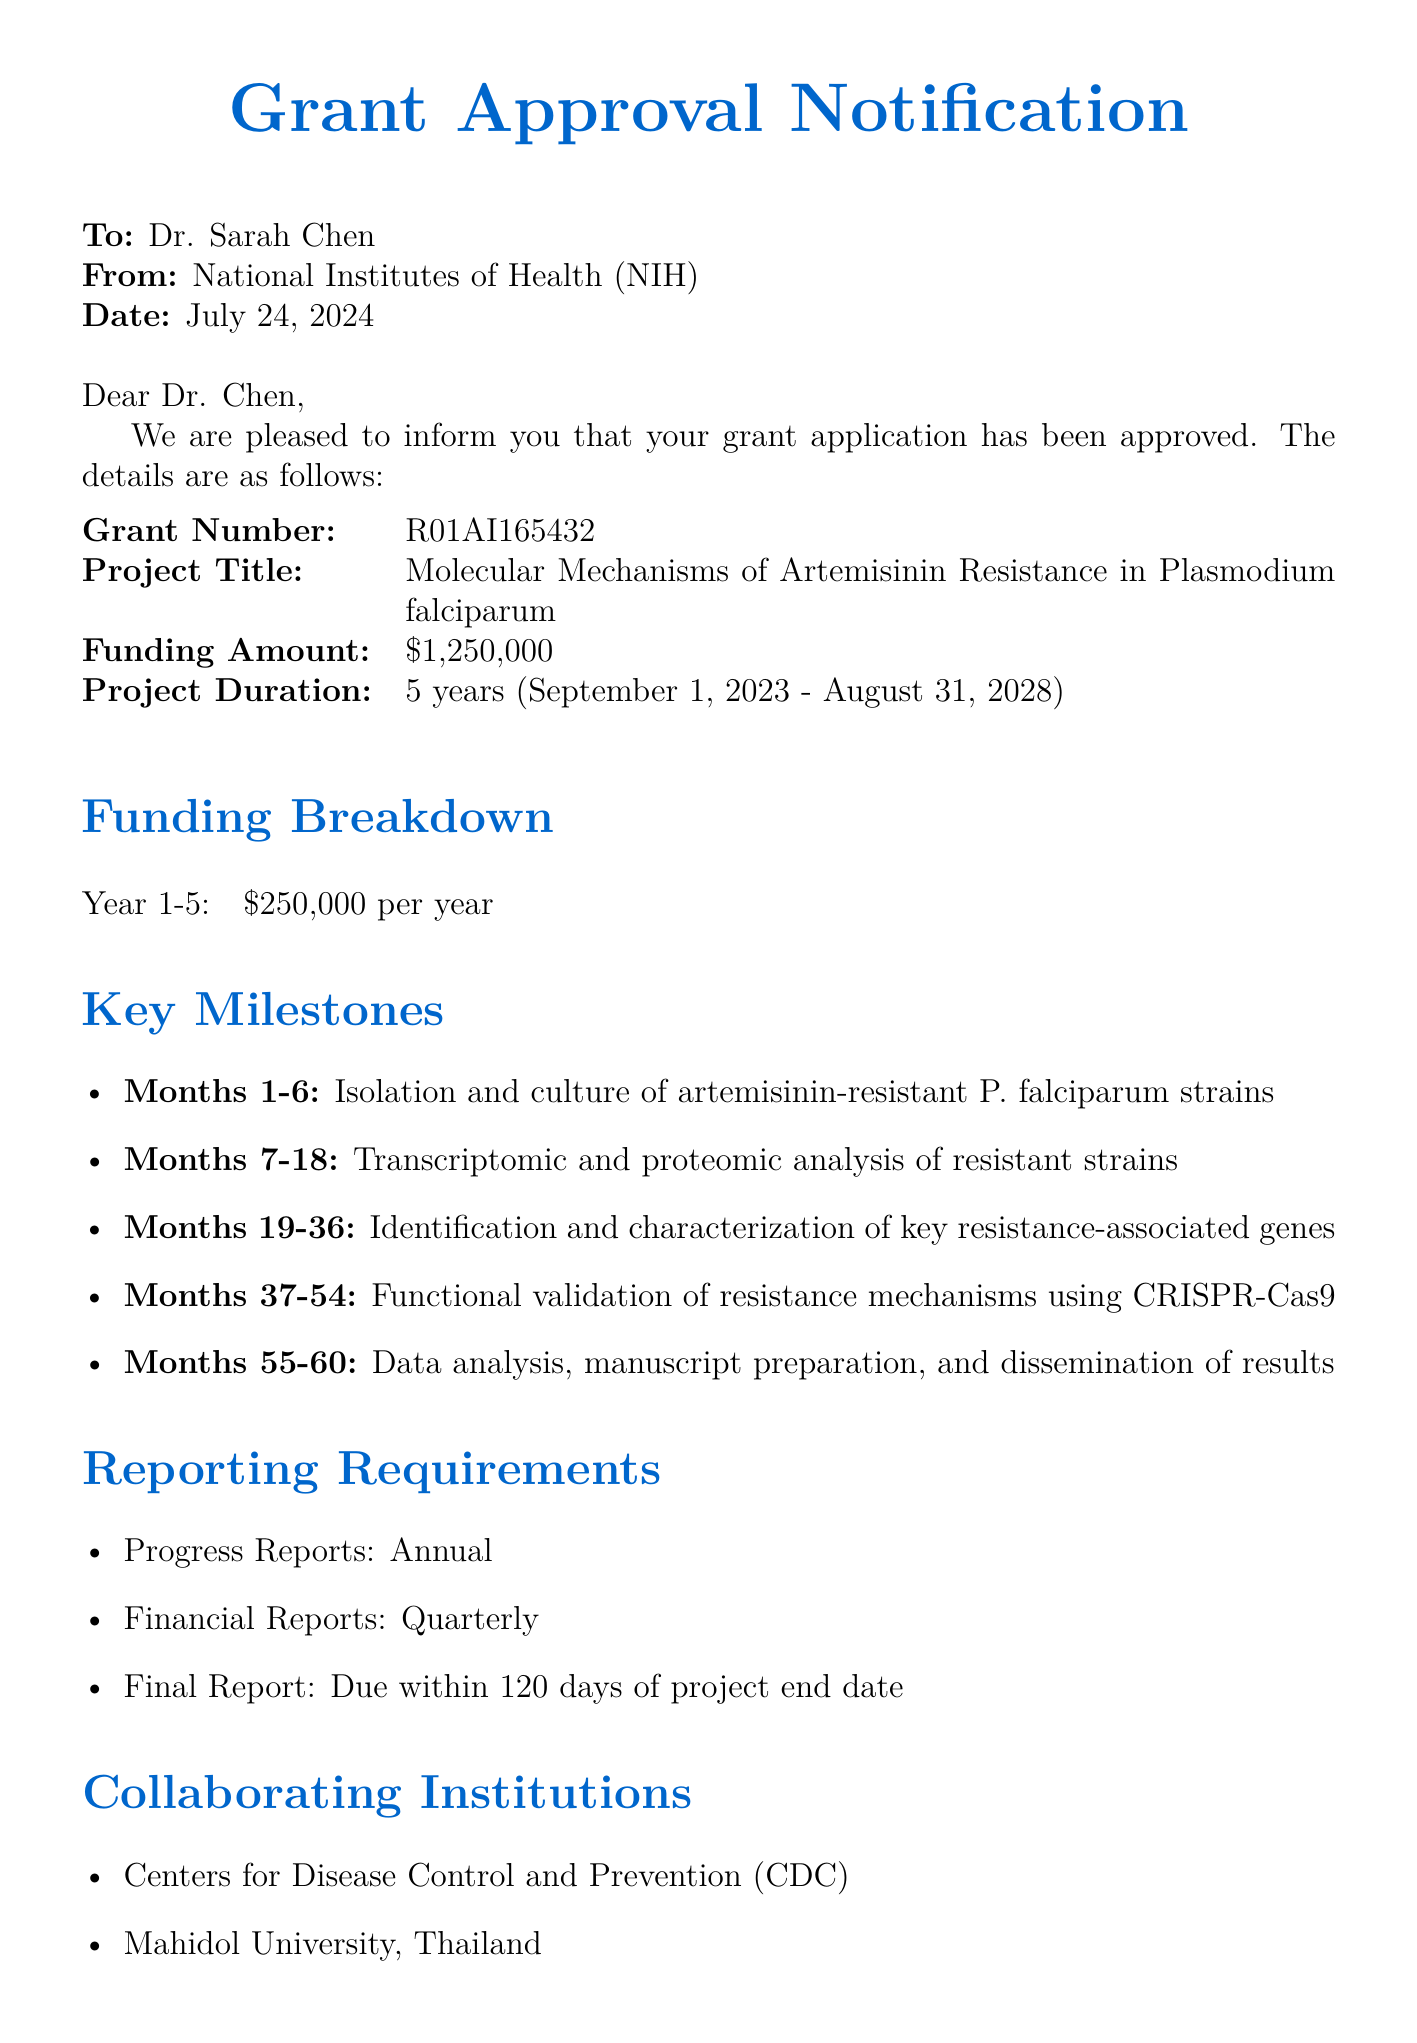What is the grant number? The grant number is explicitly mentioned in the document, which is R01AI165432.
Answer: R01AI165432 What is the total funding amount for the project? The total funding amount is listed as $1,250,000 in the document.
Answer: $1,250,000 How long is the project duration? The document specifies the project duration as 5 years.
Answer: 5 years Who is the program officer? The document names the program officer responsible, which is Dr. Michael Johnson.
Answer: Dr. Michael Johnson What is the main focus of the project? The project title in the document indicates the focus is on artemisinin resistance in Plasmodium falciparum.
Answer: Molecular Mechanisms of Artemisinin Resistance in Plasmodium falciparum What are the reporting requirements for progress reports? The document states that progress reports are required annually.
Answer: Annual In which year will the isolation and culture of artemisinin-resistant strains take place? The key milestone indicates this activity occurs in the first 6 months, aligning with the start date of the project.
Answer: Months 1-6 What types of analysis will be conducted on resistant strains? The document specifies transcriptomic and proteomic analysis as part of the study activities.
Answer: Transcriptomic and proteomic analysis Which institution is collaborating on this project? The document lists collaborating institutions, including the Centers for Disease Control and Prevention (CDC).
Answer: Centers for Disease Control and Prevention (CDC) 